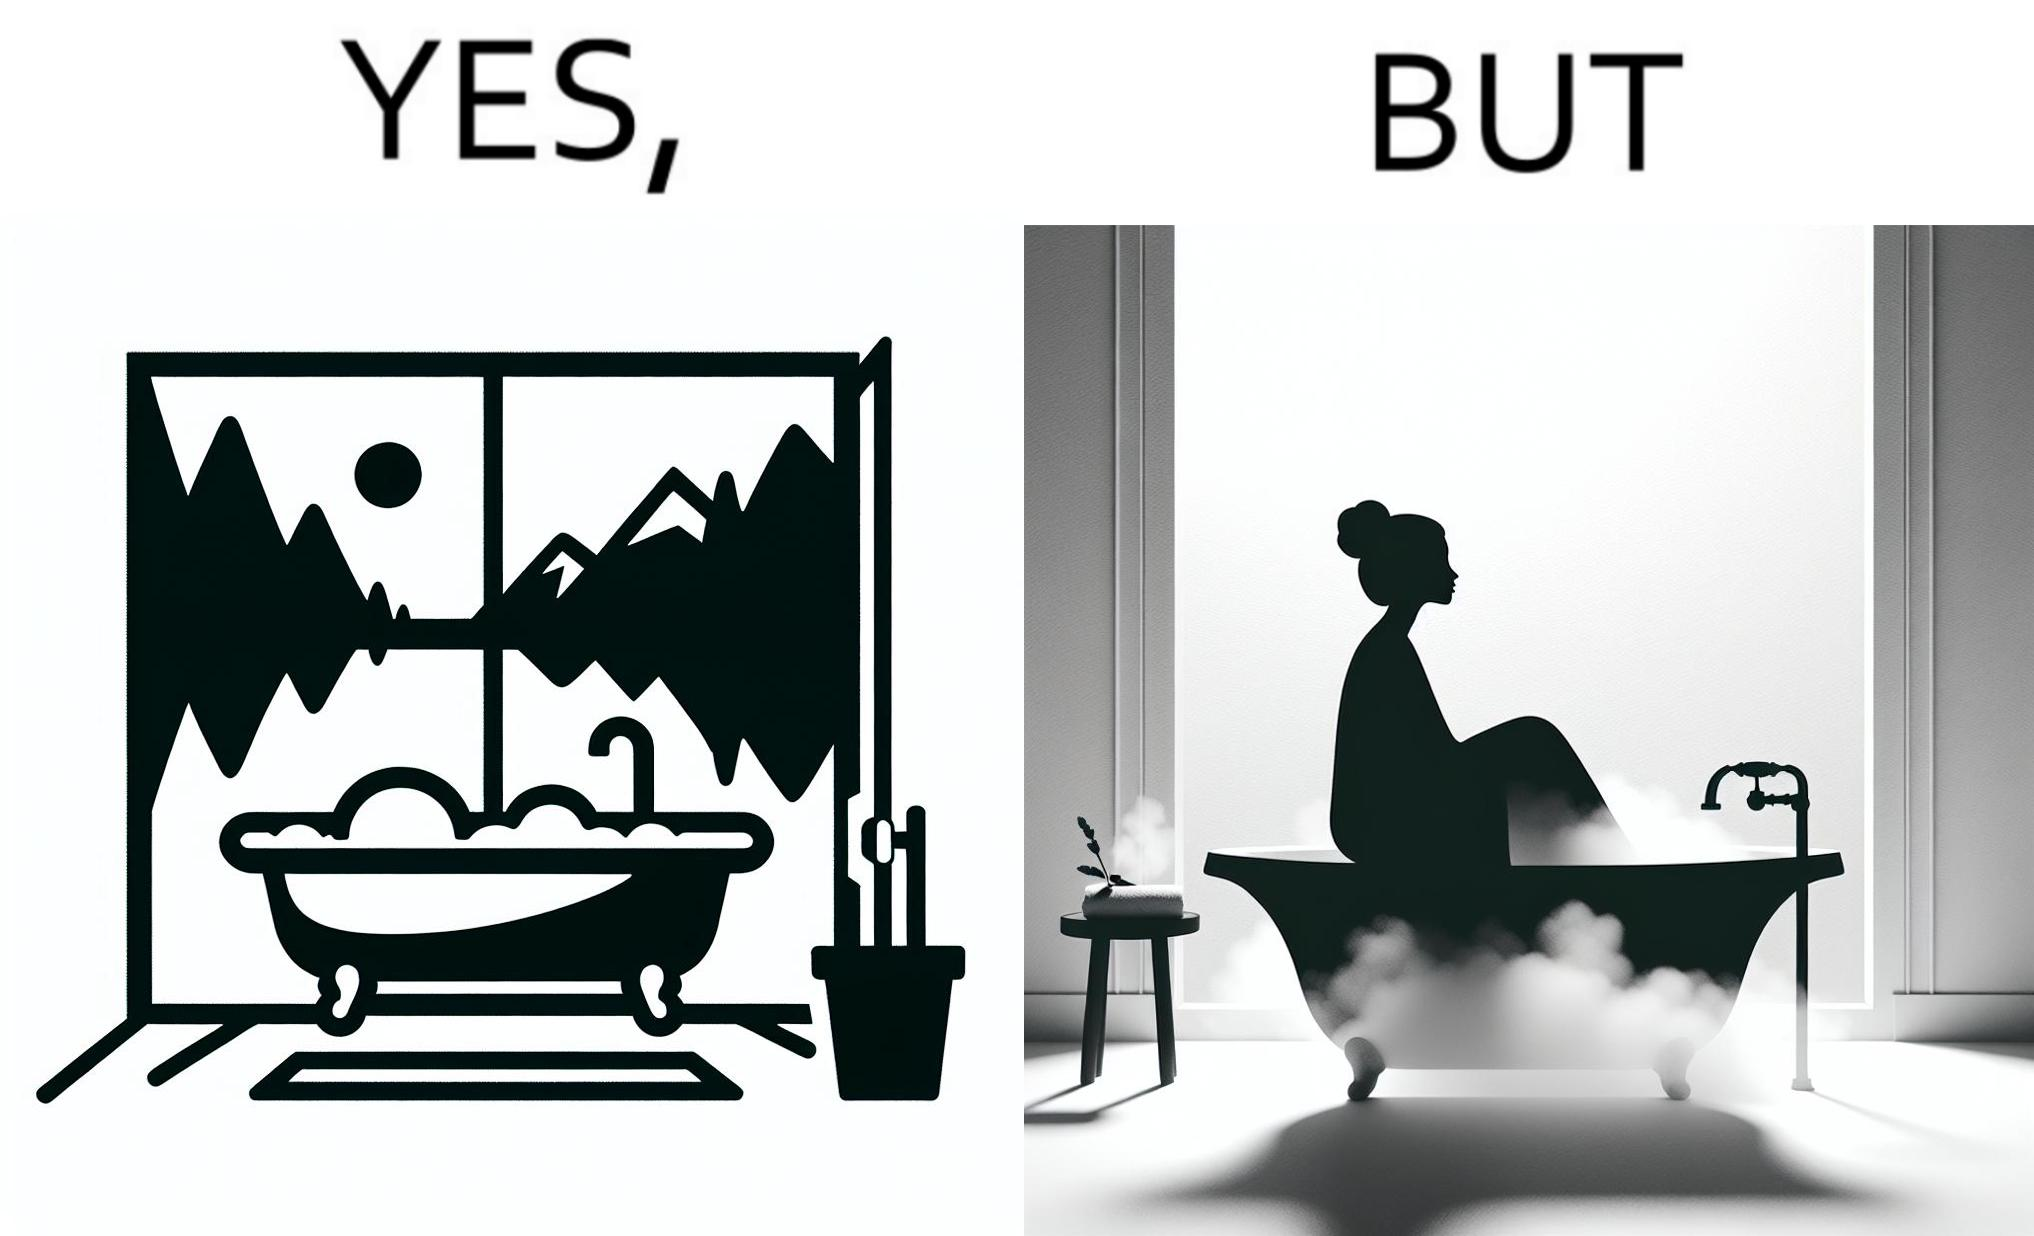Provide a description of this image. The image is ironical, as a bathtub near a window having a very scenic view, becomes misty when someone is bathing, thus making the scenic view blurry. 